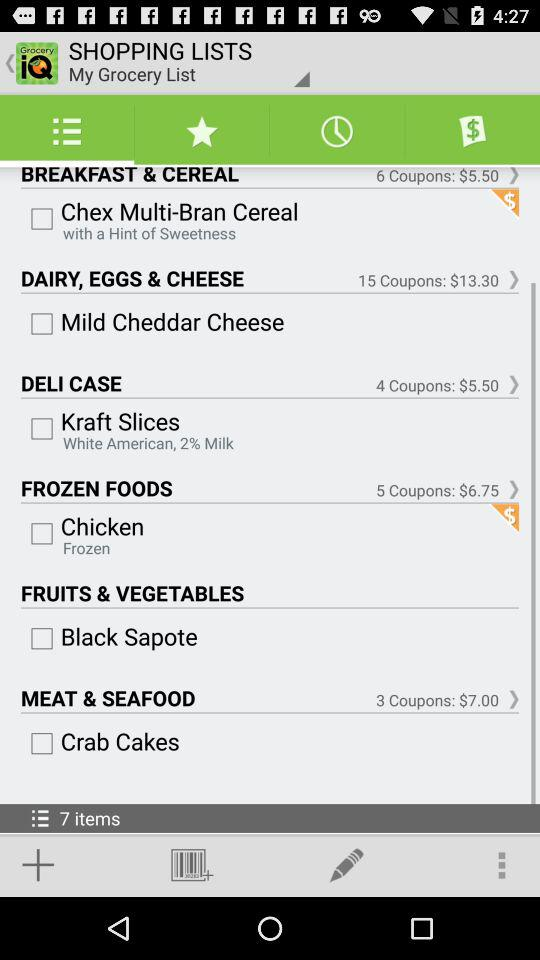How much do coupons cost for "MEAT & SEAFOOD"? The coupon cost is $7.00. 